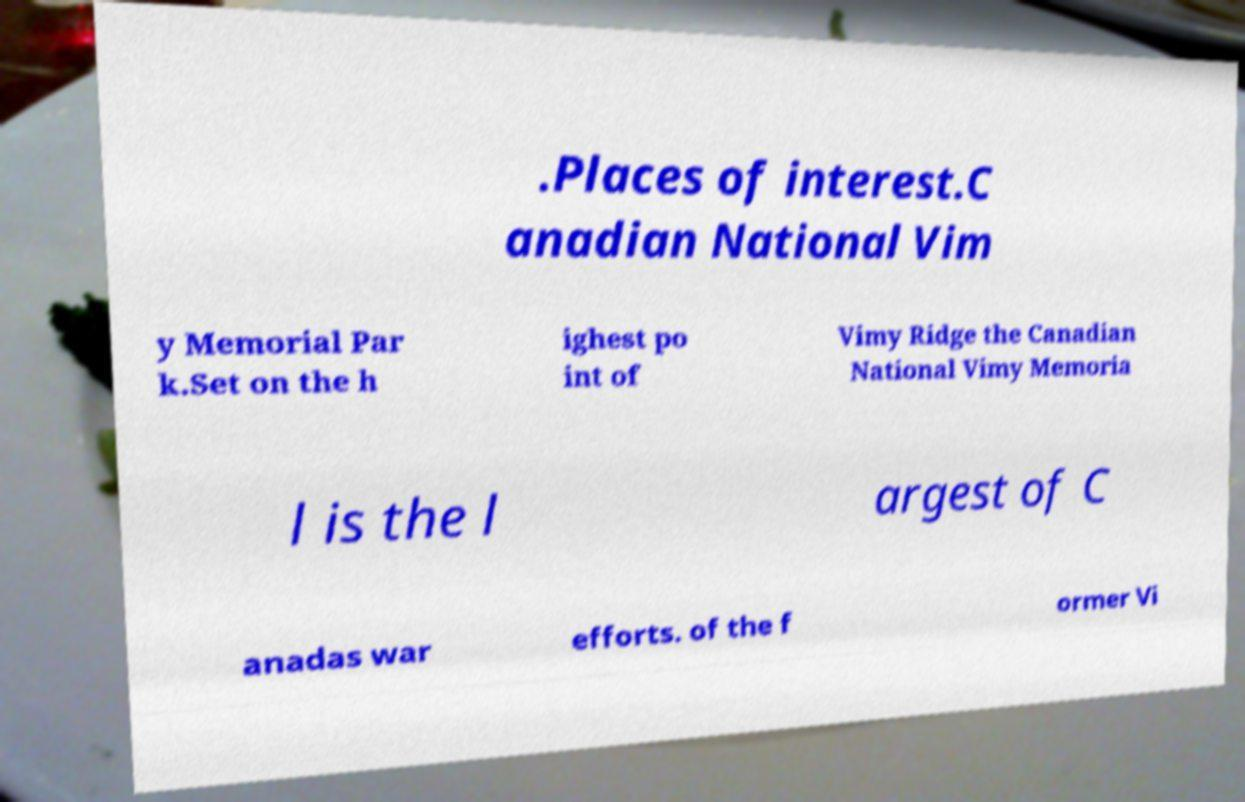Could you extract and type out the text from this image? .Places of interest.C anadian National Vim y Memorial Par k.Set on the h ighest po int of Vimy Ridge the Canadian National Vimy Memoria l is the l argest of C anadas war efforts. of the f ormer Vi 